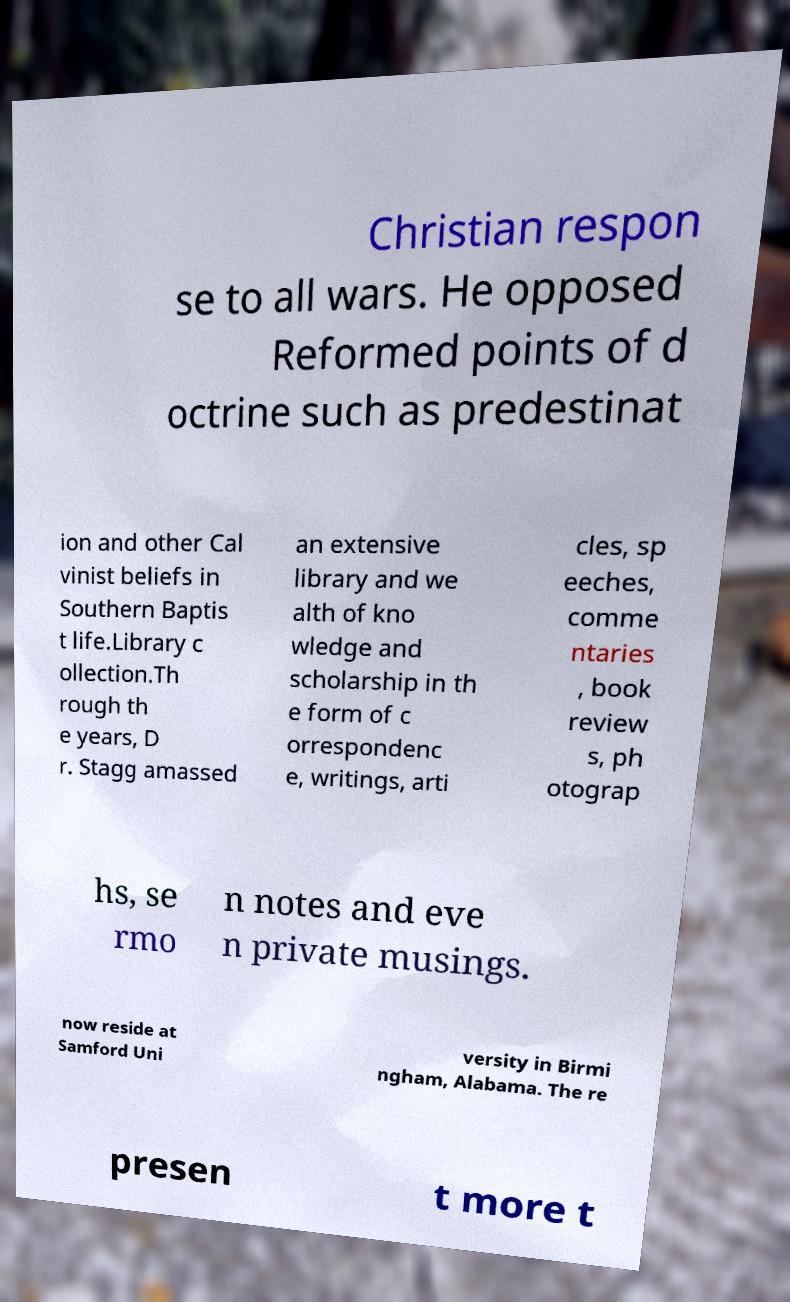Can you accurately transcribe the text from the provided image for me? Christian respon se to all wars. He opposed Reformed points of d octrine such as predestinat ion and other Cal vinist beliefs in Southern Baptis t life.Library c ollection.Th rough th e years, D r. Stagg amassed an extensive library and we alth of kno wledge and scholarship in th e form of c orrespondenc e, writings, arti cles, sp eeches, comme ntaries , book review s, ph otograp hs, se rmo n notes and eve n private musings. now reside at Samford Uni versity in Birmi ngham, Alabama. The re presen t more t 